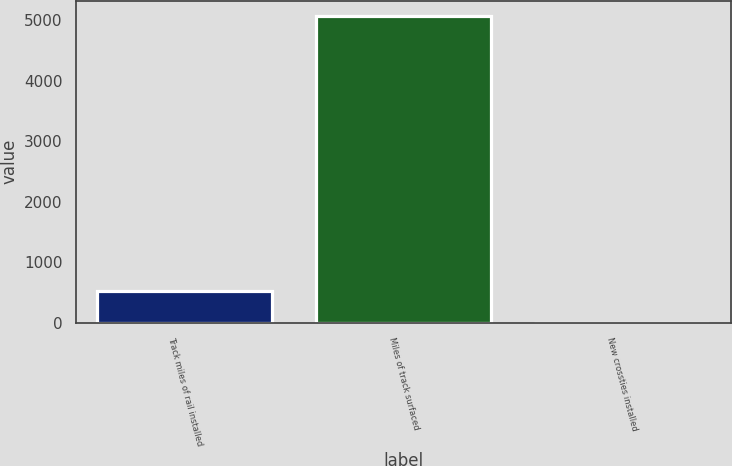Convert chart. <chart><loc_0><loc_0><loc_500><loc_500><bar_chart><fcel>Track miles of rail installed<fcel>Miles of track surfaced<fcel>New crossties installed<nl><fcel>523<fcel>5074<fcel>2.4<nl></chart> 